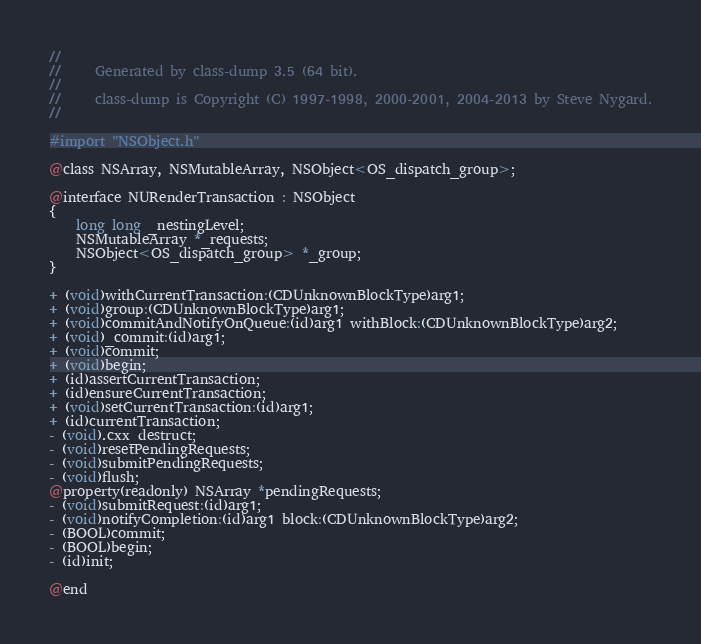<code> <loc_0><loc_0><loc_500><loc_500><_C_>//
//     Generated by class-dump 3.5 (64 bit).
//
//     class-dump is Copyright (C) 1997-1998, 2000-2001, 2004-2013 by Steve Nygard.
//

#import "NSObject.h"

@class NSArray, NSMutableArray, NSObject<OS_dispatch_group>;

@interface NURenderTransaction : NSObject
{
    long long _nestingLevel;
    NSMutableArray *_requests;
    NSObject<OS_dispatch_group> *_group;
}

+ (void)withCurrentTransaction:(CDUnknownBlockType)arg1;
+ (void)group:(CDUnknownBlockType)arg1;
+ (void)commitAndNotifyOnQueue:(id)arg1 withBlock:(CDUnknownBlockType)arg2;
+ (void)_commit:(id)arg1;
+ (void)commit;
+ (void)begin;
+ (id)assertCurrentTransaction;
+ (id)ensureCurrentTransaction;
+ (void)setCurrentTransaction:(id)arg1;
+ (id)currentTransaction;
- (void).cxx_destruct;
- (void)resetPendingRequests;
- (void)submitPendingRequests;
- (void)flush;
@property(readonly) NSArray *pendingRequests;
- (void)submitRequest:(id)arg1;
- (void)notifyCompletion:(id)arg1 block:(CDUnknownBlockType)arg2;
- (BOOL)commit;
- (BOOL)begin;
- (id)init;

@end

</code> 